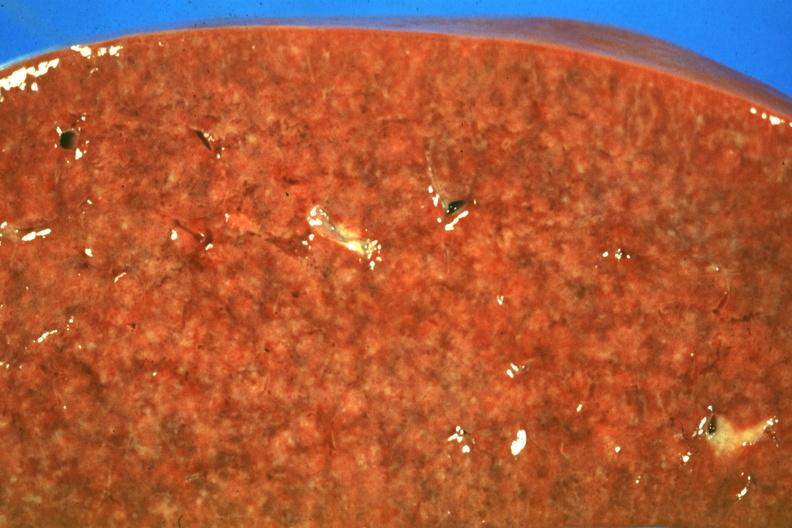s hematologic present?
Answer the question using a single word or phrase. Yes 